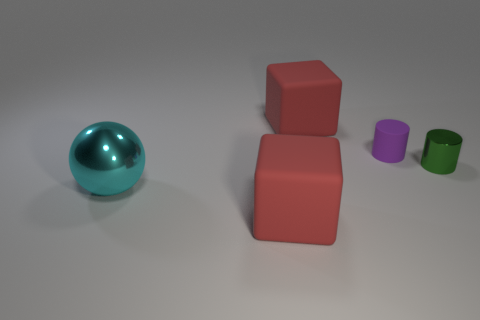Add 4 large blue objects. How many objects exist? 9 Subtract all spheres. How many objects are left? 4 Add 2 purple shiny objects. How many purple shiny objects exist? 2 Subtract 0 cyan cylinders. How many objects are left? 5 Subtract all brown metal objects. Subtract all big cyan metallic balls. How many objects are left? 4 Add 2 red objects. How many red objects are left? 4 